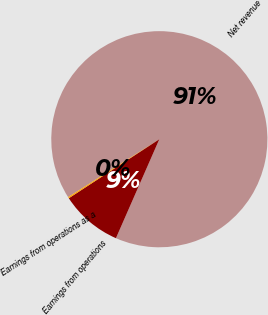<chart> <loc_0><loc_0><loc_500><loc_500><pie_chart><fcel>Net revenue<fcel>Earnings from operations<fcel>Earnings from operations as a<nl><fcel>90.58%<fcel>9.23%<fcel>0.19%<nl></chart> 